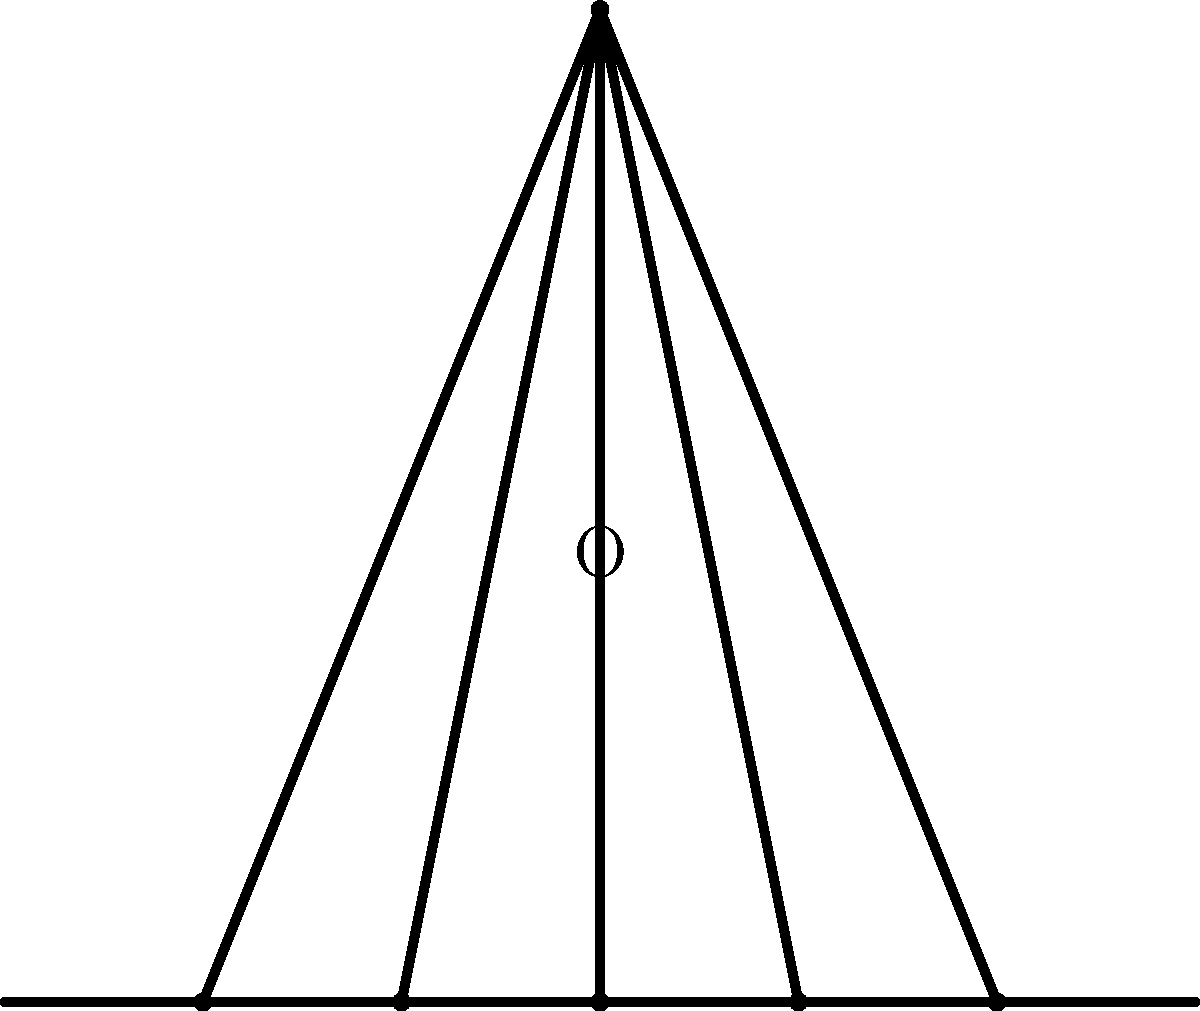Consider the traditional seven-branched Menorah, a symbol deeply rooted in Jewish history and culture. The Menorah possesses rotational symmetry around its central axis. If we rotate the Menorah by an angle $\theta$ around point O, as shown in the diagram, what is the smallest positive value of $\theta$ (in degrees) that will result in the Menorah appearing identical to its original position? To solve this problem, we need to consider the rotational symmetry of the Menorah:

1. The Menorah has 7 branches in total: 3 on each side and 1 in the center.

2. The Menorah is symmetrical, meaning it looks the same on both sides of the central branch.

3. To determine the smallest rotation that brings the Menorah back to its original position, we need to consider how many unique positions it can have in a full 360° rotation.

4. Since the Menorah has bilateral symmetry, it will appear the same after a 180° rotation.

5. Therefore, there are only two unique positions in a full rotation: the original position and the position after a 180° rotation.

6. The number of unique positions determines the rotational symmetry order. In this case, the order is 2.

7. To calculate the smallest rotation angle, we divide 360° by the order of rotational symmetry:

   $\theta = \frac{360°}{2} = 180°$

Thus, the smallest positive angle that will return the Menorah to its original position is 180°.
Answer: 180° 